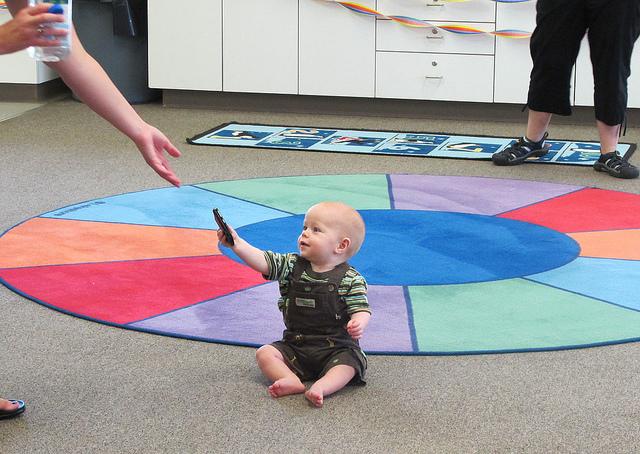What is the adult holding in their right hand?
Write a very short answer. Glass. What is in the baby's hand?
Write a very short answer. Phone. Is the baby clothed?
Give a very brief answer. Yes. 